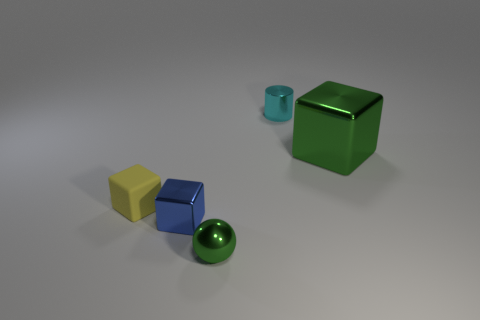How would you describe the textures of the different objects in the image? In the image, each object exhibits a unique texture; the green cube and the small blue cylinder possess a glossy, reflective finish, indicative of a metallic surface. The yellow and blue blocks appear to have a matte finish resembling plastic or painted wood, while the green sphere's surface looks smooth and could be either glass or a polished stone. 